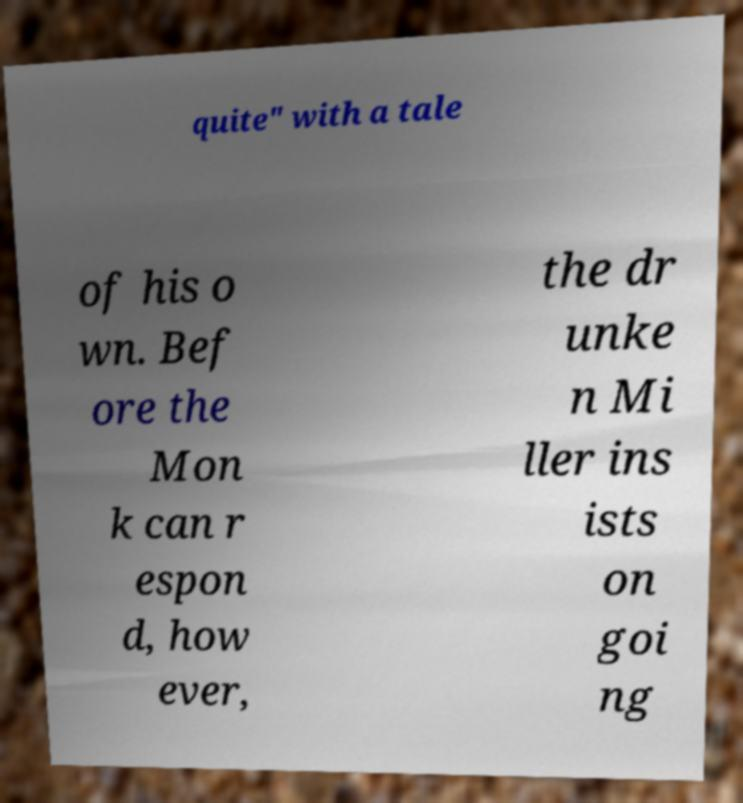What messages or text are displayed in this image? I need them in a readable, typed format. quite" with a tale of his o wn. Bef ore the Mon k can r espon d, how ever, the dr unke n Mi ller ins ists on goi ng 